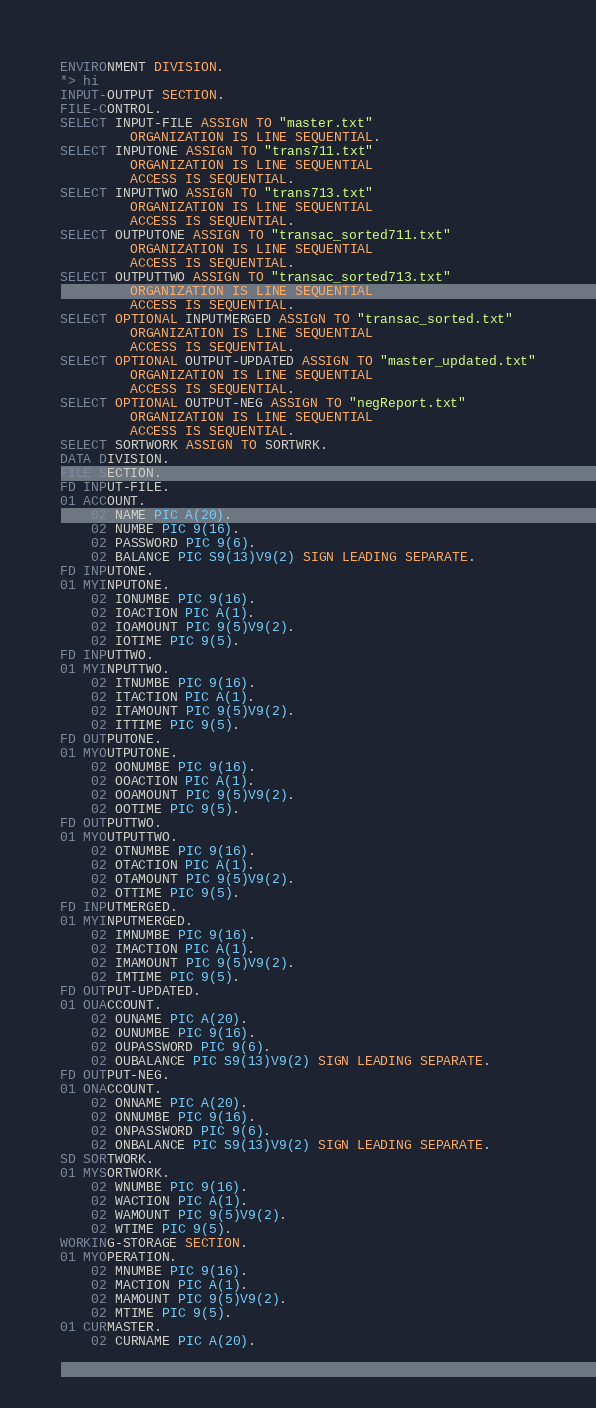<code> <loc_0><loc_0><loc_500><loc_500><_COBOL_>ENVIRONMENT DIVISION.
*> hi
INPUT-OUTPUT SECTION.
FILE-CONTROL.
SELECT INPUT-FILE ASSIGN TO "master.txt"
         ORGANIZATION IS LINE SEQUENTIAL.
SELECT INPUTONE ASSIGN TO "trans711.txt"
         ORGANIZATION IS LINE SEQUENTIAL
         ACCESS IS SEQUENTIAL.
SELECT INPUTTWO ASSIGN TO "trans713.txt"
         ORGANIZATION IS LINE SEQUENTIAL
         ACCESS IS SEQUENTIAL.
SELECT OUTPUTONE ASSIGN TO "transac_sorted711.txt"
         ORGANIZATION IS LINE SEQUENTIAL
         ACCESS IS SEQUENTIAL.
SELECT OUTPUTTWO ASSIGN TO "transac_sorted713.txt"
         ORGANIZATION IS LINE SEQUENTIAL
         ACCESS IS SEQUENTIAL.
SELECT OPTIONAL INPUTMERGED ASSIGN TO "transac_sorted.txt"
         ORGANIZATION IS LINE SEQUENTIAL
         ACCESS IS SEQUENTIAL.
SELECT OPTIONAL OUTPUT-UPDATED ASSIGN TO "master_updated.txt"
         ORGANIZATION IS LINE SEQUENTIAL
         ACCESS IS SEQUENTIAL.
SELECT OPTIONAL OUTPUT-NEG ASSIGN TO "negReport.txt"
         ORGANIZATION IS LINE SEQUENTIAL
         ACCESS IS SEQUENTIAL.
SELECT SORTWORK ASSIGN TO SORTWRK.
DATA DIVISION.
FILE SECTION.
FD INPUT-FILE.
01 ACCOUNT.
    02 NAME PIC A(20).
    02 NUMBE PIC 9(16).
    02 PASSWORD PIC 9(6).
    02 BALANCE PIC S9(13)V9(2) SIGN LEADING SEPARATE.
FD INPUTONE.
01 MYINPUTONE.
    02 IONUMBE PIC 9(16).
    02 IOACTION PIC A(1).
    02 IOAMOUNT PIC 9(5)V9(2).
    02 IOTIME PIC 9(5).
FD INPUTTWO.
01 MYINPUTTWO.
    02 ITNUMBE PIC 9(16).
    02 ITACTION PIC A(1).
    02 ITAMOUNT PIC 9(5)V9(2).
    02 ITTIME PIC 9(5).
FD OUTPUTONE.
01 MYOUTPUTONE.
    02 OONUMBE PIC 9(16).
    02 OOACTION PIC A(1).
    02 OOAMOUNT PIC 9(5)V9(2).
    02 OOTIME PIC 9(5).
FD OUTPUTTWO.
01 MYOUTPUTTWO.
    02 OTNUMBE PIC 9(16).
    02 OTACTION PIC A(1).
    02 OTAMOUNT PIC 9(5)V9(2).
    02 OTTIME PIC 9(5).
FD INPUTMERGED.
01 MYINPUTMERGED.
    02 IMNUMBE PIC 9(16).
    02 IMACTION PIC A(1).
    02 IMAMOUNT PIC 9(5)V9(2).
    02 IMTIME PIC 9(5).
FD OUTPUT-UPDATED.
01 OUACCOUNT.
    02 OUNAME PIC A(20).
    02 OUNUMBE PIC 9(16).
    02 OUPASSWORD PIC 9(6).
    02 OUBALANCE PIC S9(13)V9(2) SIGN LEADING SEPARATE.
FD OUTPUT-NEG.
01 ONACCOUNT.
    02 ONNAME PIC A(20).
    02 ONNUMBE PIC 9(16).
    02 ONPASSWORD PIC 9(6).
    02 ONBALANCE PIC S9(13)V9(2) SIGN LEADING SEPARATE.
SD SORTWORK.
01 MYSORTWORK.
    02 WNUMBE PIC 9(16).
    02 WACTION PIC A(1).
    02 WAMOUNT PIC 9(5)V9(2).
    02 WTIME PIC 9(5).
WORKING-STORAGE SECTION.
01 MYOPERATION.
    02 MNUMBE PIC 9(16).
    02 MACTION PIC A(1).
    02 MAMOUNT PIC 9(5)V9(2).
    02 MTIME PIC 9(5).
01 CURMASTER.
    02 CURNAME PIC A(20).</code> 